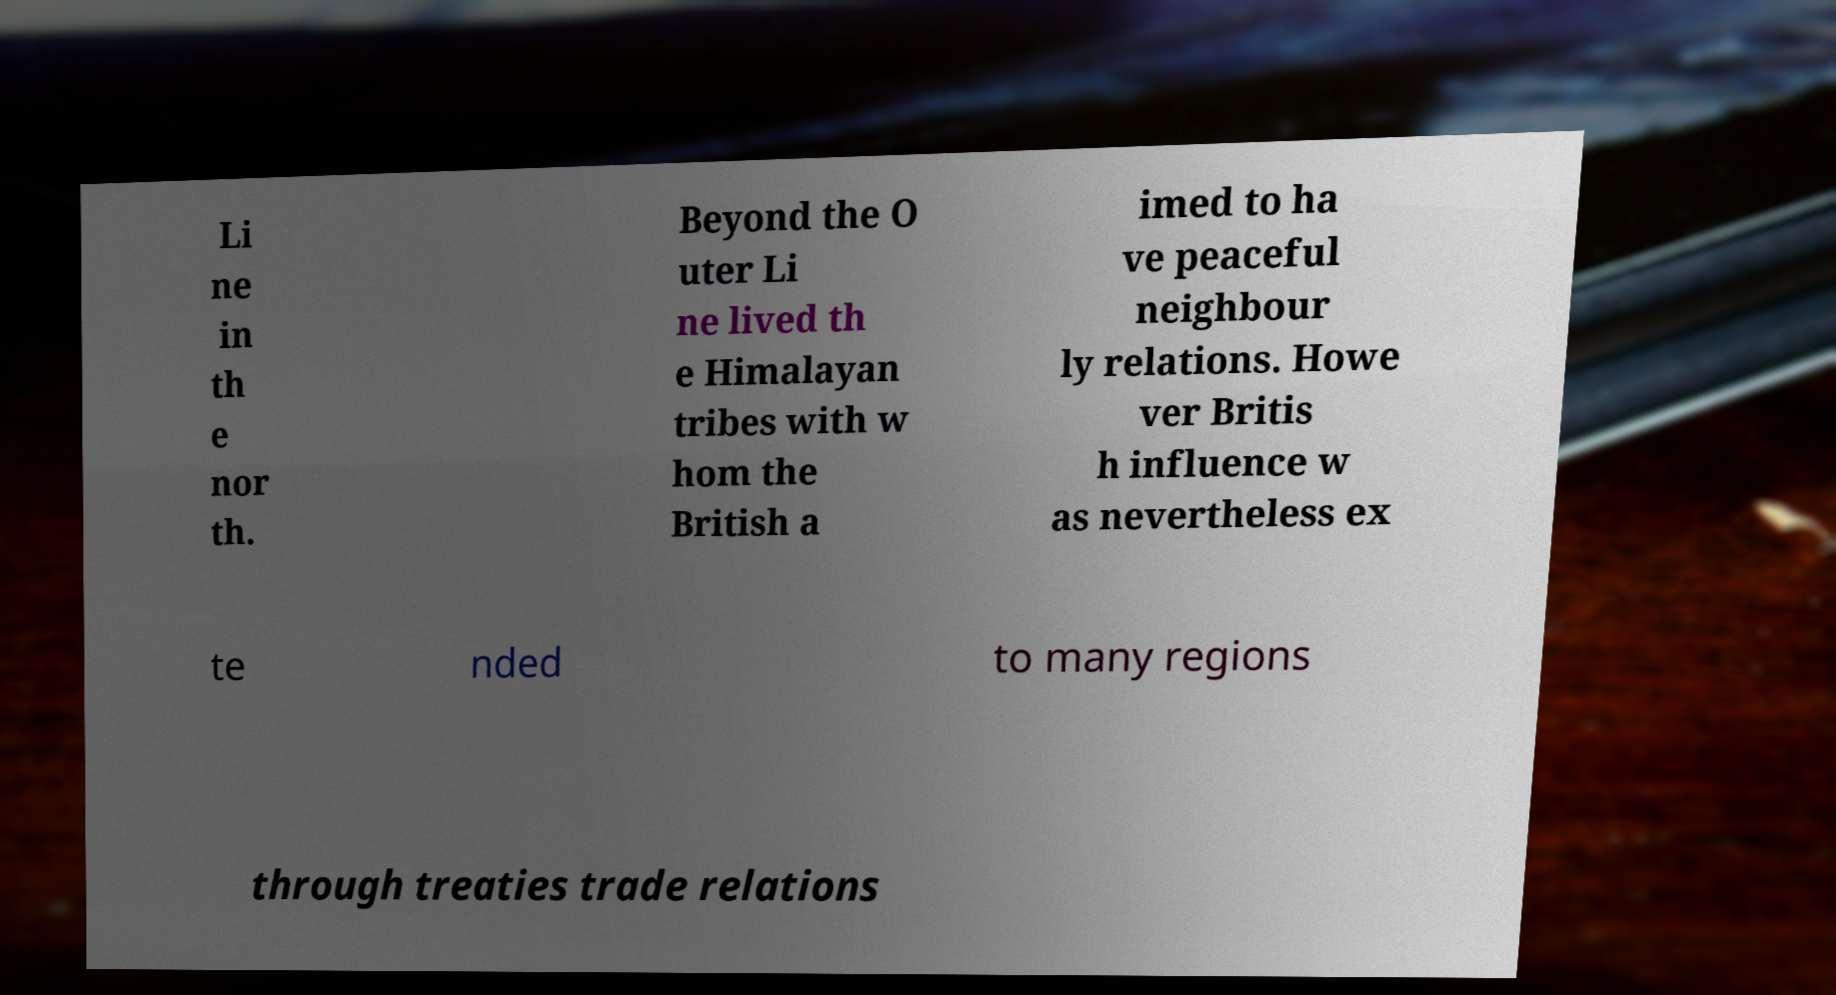Please read and relay the text visible in this image. What does it say? Li ne in th e nor th. Beyond the O uter Li ne lived th e Himalayan tribes with w hom the British a imed to ha ve peaceful neighbour ly relations. Howe ver Britis h influence w as nevertheless ex te nded to many regions through treaties trade relations 